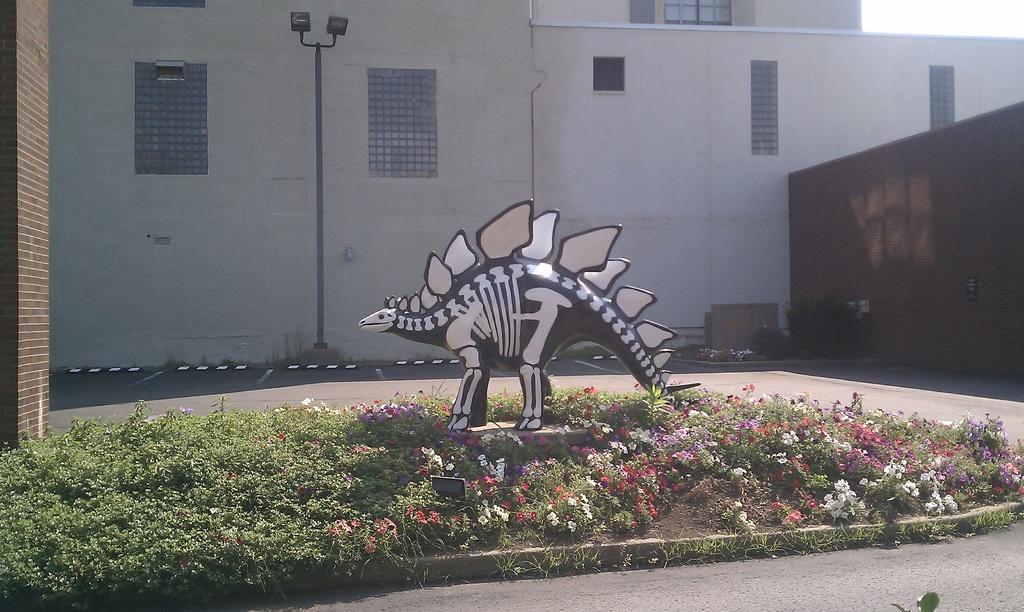In one or two sentences, can you explain what this image depicts? This image is taken outdoors. At the bottom of the image there is a road and a ground with grass and many flowers on it. In the middle of the image there is an artificial dinosaur. In the background there is a building with walls, windows and a roof and there is a street light. 